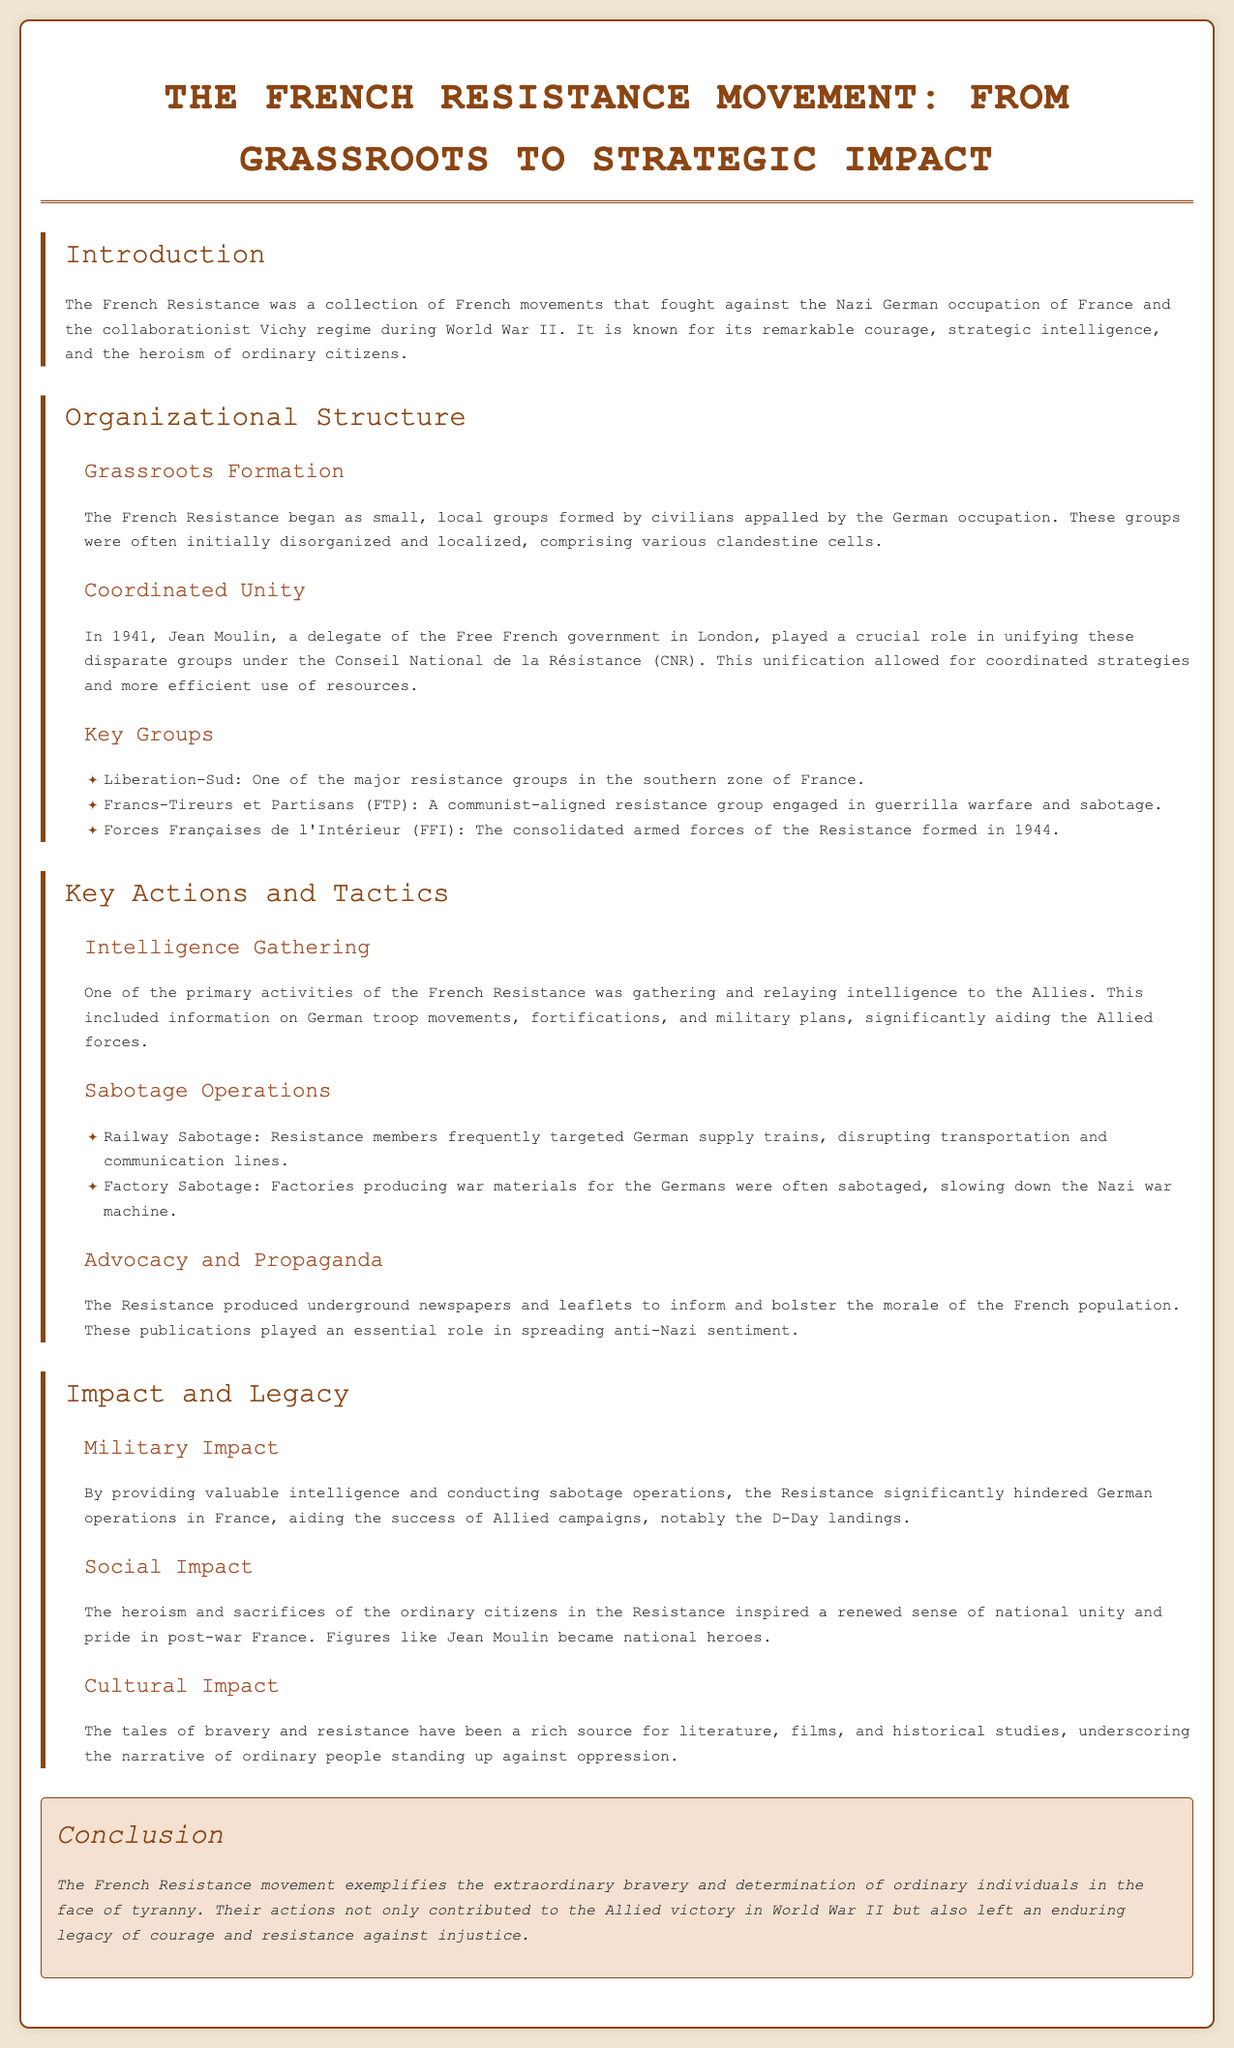What is the main goal of the French Resistance? The main goal was to fight against the Nazi German occupation of France and the collaborationist Vichy regime during World War II.
Answer: To fight against fascism Who unified the disparate groups of the French Resistance? Jean Moulin played a crucial role in unifying the different groups under the Conseil National de la Résistance (CNR).
Answer: Jean Moulin What was one of the primary activities of the French Resistance? Gathering and relaying intelligence to the Allies about German troop movements and military plans.
Answer: Intelligence Gathering Which two types of sabotage operations did the Resistance conduct? They targeted railway supply trains and factories producing war materials for the Germans.
Answer: Railway and Factory Sabotage What year was the Conseil National de la Résistance established? The unification under the CNR occurred in 1941.
Answer: 1941 What impact did the Resistance have on post-war French society? The actions inspired a renewed sense of national unity and pride, making figures like Jean Moulin national heroes.
Answer: National unity and pride What form of communication did the Resistance use to bolster morale? The Resistance produced underground newspapers and leaflets to inform the French population.
Answer: Underground newspapers What is emphasized in the conclusion of the document? The extraordinary bravery and determination of ordinary individuals in the face of tyranny is highlighted.
Answer: Bravery and determination What major Allied campaign did the Resistance aid? The Resistance significantly aided the success of the D-Day landings.
Answer: D-Day landings 